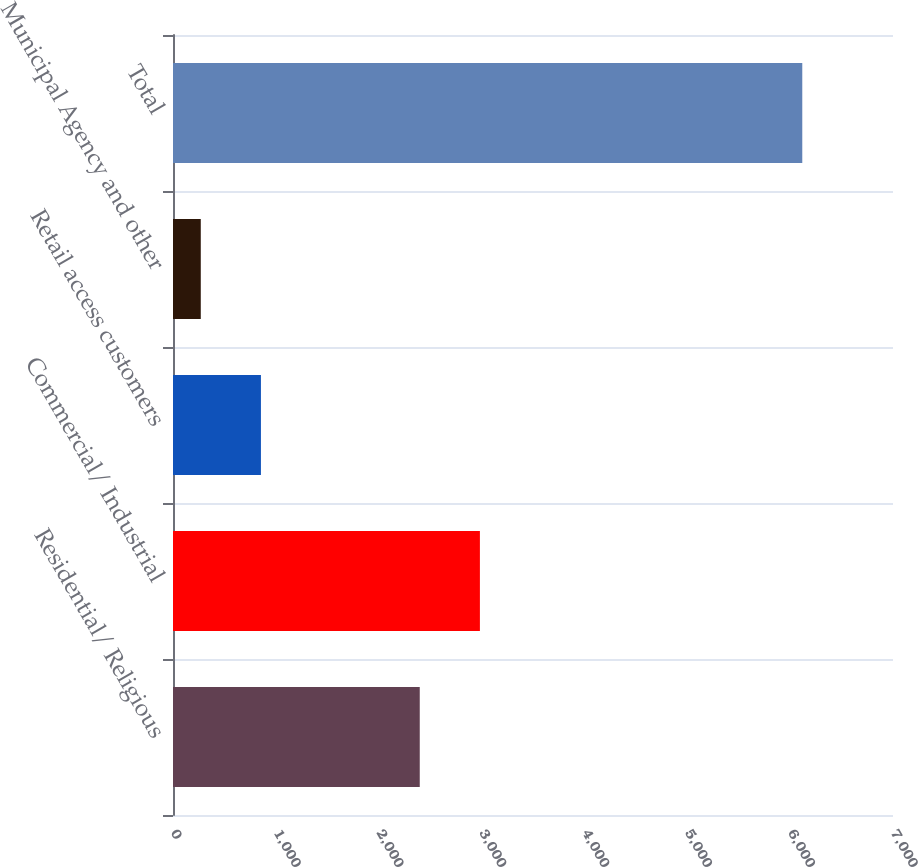<chart> <loc_0><loc_0><loc_500><loc_500><bar_chart><fcel>Residential/ Religious<fcel>Commercial/ Industrial<fcel>Retail access customers<fcel>Municipal Agency and other<fcel>Total<nl><fcel>2399<fcel>2983.8<fcel>854.8<fcel>270<fcel>6118<nl></chart> 